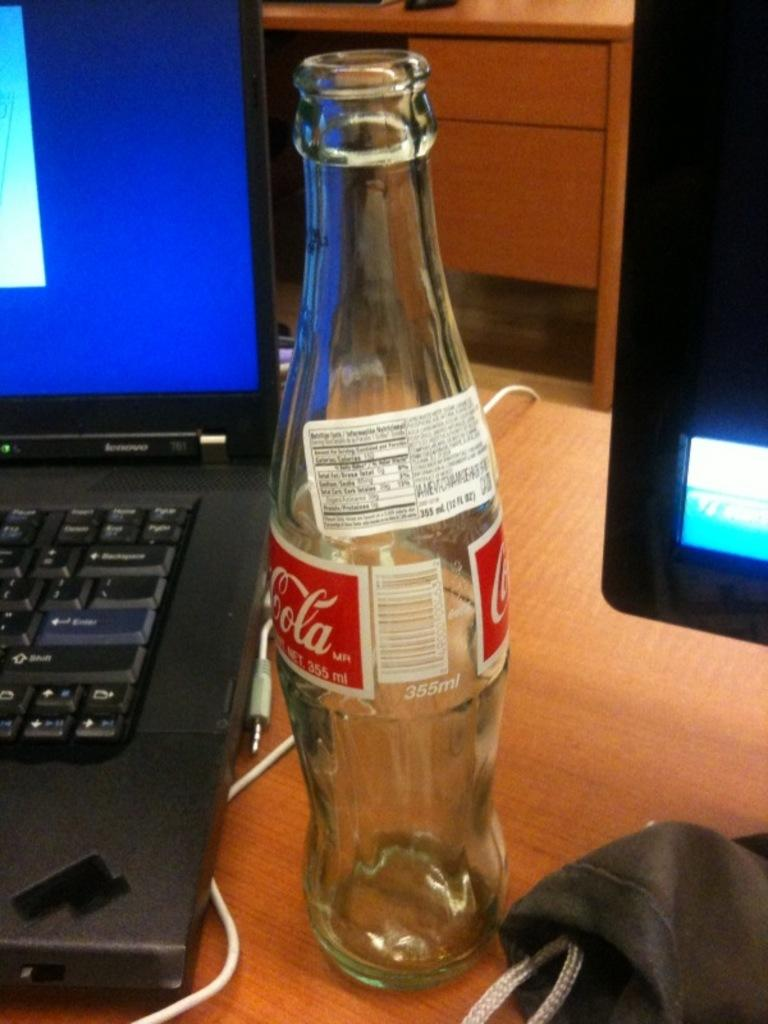Provide a one-sentence caption for the provided image. A Cola bottle sitting in between a laptop computer and computer monitor. 